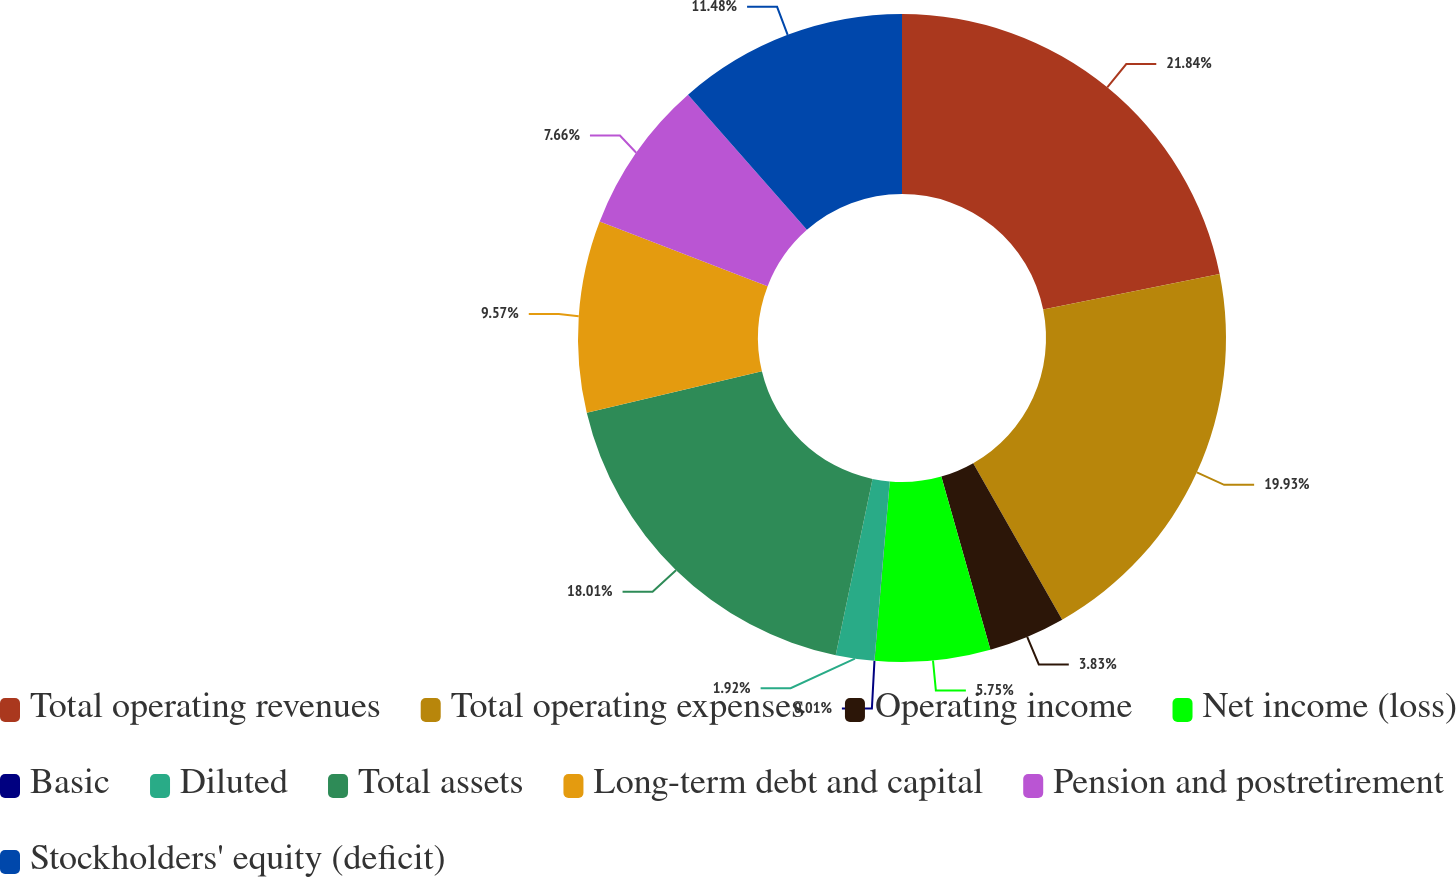Convert chart. <chart><loc_0><loc_0><loc_500><loc_500><pie_chart><fcel>Total operating revenues<fcel>Total operating expenses<fcel>Operating income<fcel>Net income (loss)<fcel>Basic<fcel>Diluted<fcel>Total assets<fcel>Long-term debt and capital<fcel>Pension and postretirement<fcel>Stockholders' equity (deficit)<nl><fcel>21.84%<fcel>19.93%<fcel>3.83%<fcel>5.75%<fcel>0.01%<fcel>1.92%<fcel>18.01%<fcel>9.57%<fcel>7.66%<fcel>11.48%<nl></chart> 